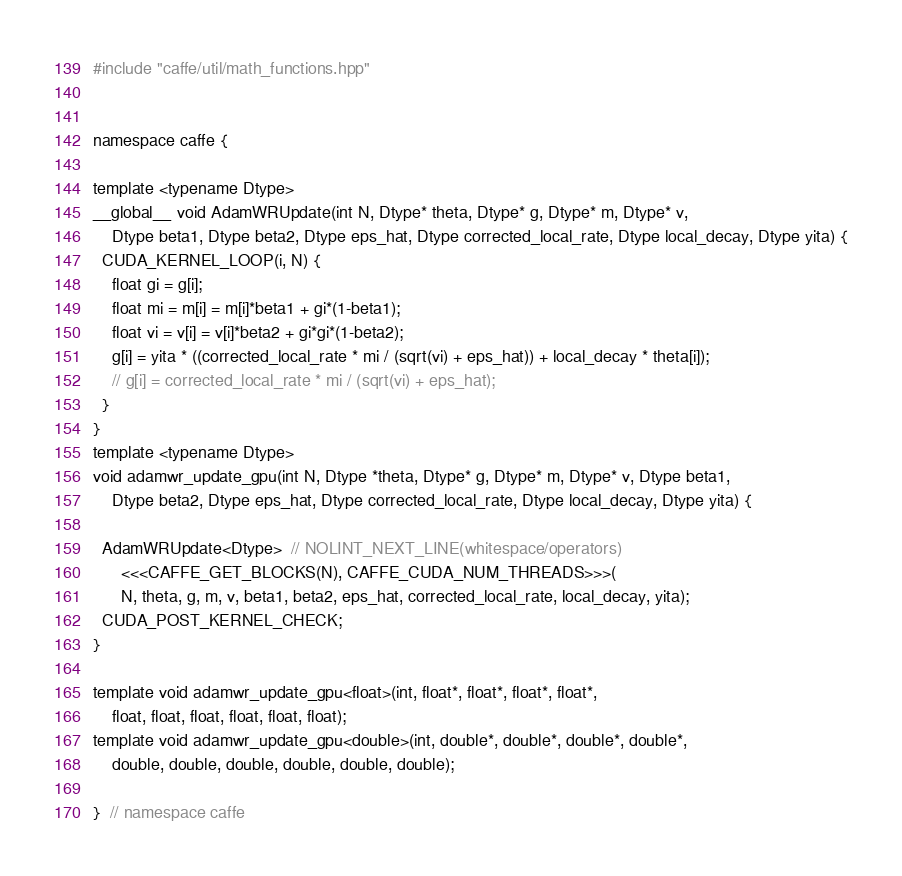Convert code to text. <code><loc_0><loc_0><loc_500><loc_500><_Cuda_>#include "caffe/util/math_functions.hpp"


namespace caffe {

template <typename Dtype>
__global__ void AdamWRUpdate(int N, Dtype* theta, Dtype* g, Dtype* m, Dtype* v,
    Dtype beta1, Dtype beta2, Dtype eps_hat, Dtype corrected_local_rate, Dtype local_decay, Dtype yita) {
  CUDA_KERNEL_LOOP(i, N) {
    float gi = g[i];
    float mi = m[i] = m[i]*beta1 + gi*(1-beta1);
    float vi = v[i] = v[i]*beta2 + gi*gi*(1-beta2);
    g[i] = yita * ((corrected_local_rate * mi / (sqrt(vi) + eps_hat)) + local_decay * theta[i]);
    // g[i] = corrected_local_rate * mi / (sqrt(vi) + eps_hat);
  }
}
template <typename Dtype>
void adamwr_update_gpu(int N, Dtype *theta, Dtype* g, Dtype* m, Dtype* v, Dtype beta1,
    Dtype beta2, Dtype eps_hat, Dtype corrected_local_rate, Dtype local_decay, Dtype yita) {

  AdamWRUpdate<Dtype>  // NOLINT_NEXT_LINE(whitespace/operators)
      <<<CAFFE_GET_BLOCKS(N), CAFFE_CUDA_NUM_THREADS>>>(
      N, theta, g, m, v, beta1, beta2, eps_hat, corrected_local_rate, local_decay, yita);
  CUDA_POST_KERNEL_CHECK;
}

template void adamwr_update_gpu<float>(int, float*, float*, float*, float*,
    float, float, float, float, float, float);
template void adamwr_update_gpu<double>(int, double*, double*, double*, double*,
    double, double, double, double, double, double);

}  // namespace caffe</code> 